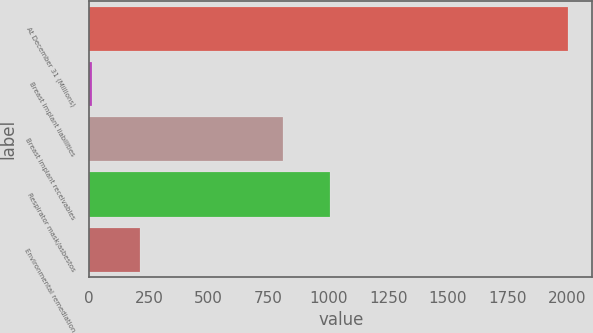Convert chart to OTSL. <chart><loc_0><loc_0><loc_500><loc_500><bar_chart><fcel>At December 31 (Millions)<fcel>Breast implant liabilities<fcel>Breast implant receivables<fcel>Respirator mask/asbestos<fcel>Environmental remediation<nl><fcel>2003<fcel>13<fcel>809<fcel>1008<fcel>212<nl></chart> 